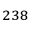<formula> <loc_0><loc_0><loc_500><loc_500>^ { 2 3 8 }</formula> 